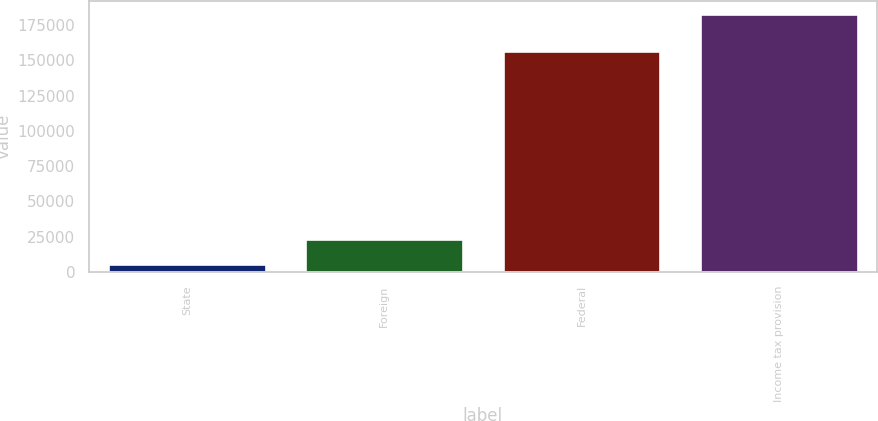Convert chart. <chart><loc_0><loc_0><loc_500><loc_500><bar_chart><fcel>State<fcel>Foreign<fcel>Federal<fcel>Income tax provision<nl><fcel>5623<fcel>23317.2<fcel>156282<fcel>182565<nl></chart> 